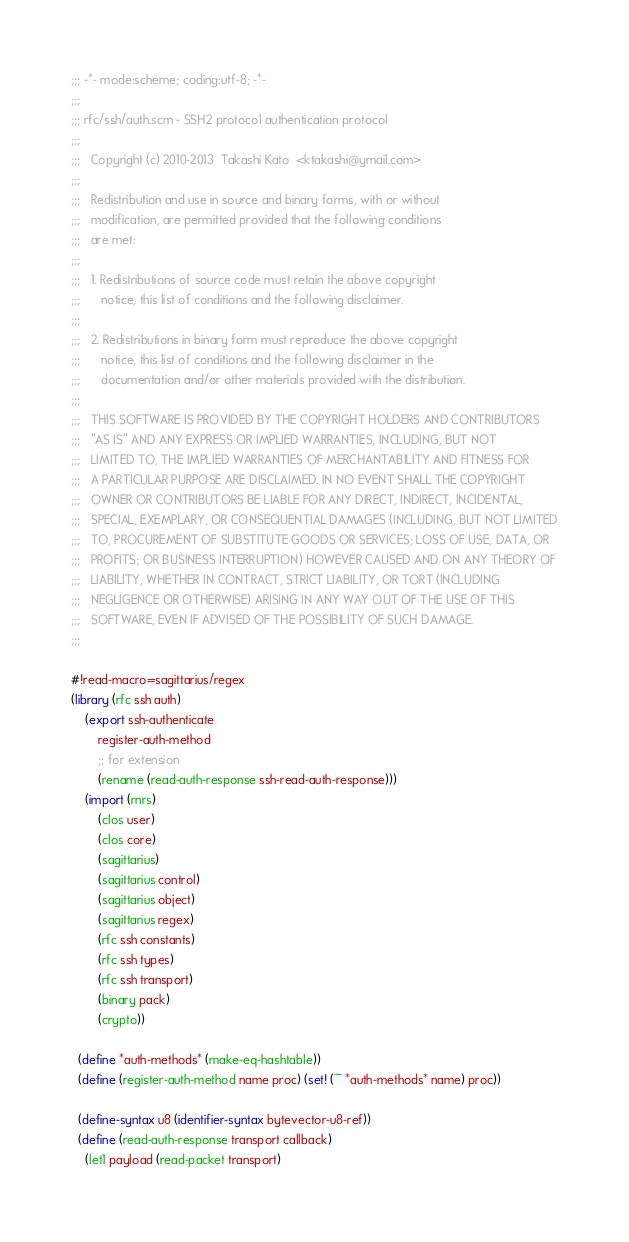Convert code to text. <code><loc_0><loc_0><loc_500><loc_500><_Scheme_>;;; -*- mode:scheme; coding:utf-8; -*-
;;;
;;; rfc/ssh/auth.scm - SSH2 protocol authentication protocol
;;;  
;;;   Copyright (c) 2010-2013  Takashi Kato  <ktakashi@ymail.com>
;;;   
;;;   Redistribution and use in source and binary forms, with or without
;;;   modification, are permitted provided that the following conditions
;;;   are met:
;;;   
;;;   1. Redistributions of source code must retain the above copyright
;;;      notice, this list of conditions and the following disclaimer.
;;;  
;;;   2. Redistributions in binary form must reproduce the above copyright
;;;      notice, this list of conditions and the following disclaimer in the
;;;      documentation and/or other materials provided with the distribution.
;;;  
;;;   THIS SOFTWARE IS PROVIDED BY THE COPYRIGHT HOLDERS AND CONTRIBUTORS
;;;   "AS IS" AND ANY EXPRESS OR IMPLIED WARRANTIES, INCLUDING, BUT NOT
;;;   LIMITED TO, THE IMPLIED WARRANTIES OF MERCHANTABILITY AND FITNESS FOR
;;;   A PARTICULAR PURPOSE ARE DISCLAIMED. IN NO EVENT SHALL THE COPYRIGHT
;;;   OWNER OR CONTRIBUTORS BE LIABLE FOR ANY DIRECT, INDIRECT, INCIDENTAL,
;;;   SPECIAL, EXEMPLARY, OR CONSEQUENTIAL DAMAGES (INCLUDING, BUT NOT LIMITED
;;;   TO, PROCUREMENT OF SUBSTITUTE GOODS OR SERVICES; LOSS OF USE, DATA, OR
;;;   PROFITS; OR BUSINESS INTERRUPTION) HOWEVER CAUSED AND ON ANY THEORY OF
;;;   LIABILITY, WHETHER IN CONTRACT, STRICT LIABILITY, OR TORT (INCLUDING
;;;   NEGLIGENCE OR OTHERWISE) ARISING IN ANY WAY OUT OF THE USE OF THIS
;;;   SOFTWARE, EVEN IF ADVISED OF THE POSSIBILITY OF SUCH DAMAGE.
;;;  

#!read-macro=sagittarius/regex
(library (rfc ssh auth)
    (export ssh-authenticate
	    register-auth-method
	    ;; for extension
	    (rename (read-auth-response ssh-read-auth-response)))
    (import (rnrs)
	    (clos user)
	    (clos core)
	    (sagittarius)
	    (sagittarius control)
	    (sagittarius object)
	    (sagittarius regex)
	    (rfc ssh constants)
	    (rfc ssh types)
	    (rfc ssh transport)
	    (binary pack)
	    (crypto))

  (define *auth-methods* (make-eq-hashtable))
  (define (register-auth-method name proc) (set! (~ *auth-methods* name) proc))

  (define-syntax u8 (identifier-syntax bytevector-u8-ref))
  (define (read-auth-response transport callback)
    (let1 payload (read-packet transport)</code> 